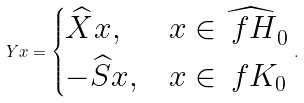Convert formula to latex. <formula><loc_0><loc_0><loc_500><loc_500>Y x = \begin{cases} \widehat { X } x , & x \in \widehat { \ f H } _ { 0 } \\ - \widehat { S } x , & x \in \ f K _ { 0 } \end{cases} .</formula> 